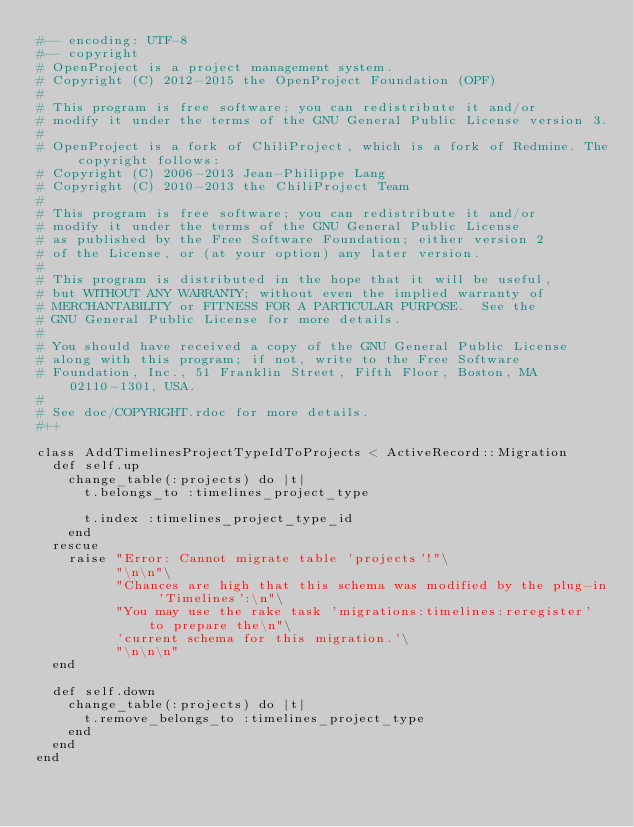<code> <loc_0><loc_0><loc_500><loc_500><_Ruby_>#-- encoding: UTF-8
#-- copyright
# OpenProject is a project management system.
# Copyright (C) 2012-2015 the OpenProject Foundation (OPF)
#
# This program is free software; you can redistribute it and/or
# modify it under the terms of the GNU General Public License version 3.
#
# OpenProject is a fork of ChiliProject, which is a fork of Redmine. The copyright follows:
# Copyright (C) 2006-2013 Jean-Philippe Lang
# Copyright (C) 2010-2013 the ChiliProject Team
#
# This program is free software; you can redistribute it and/or
# modify it under the terms of the GNU General Public License
# as published by the Free Software Foundation; either version 2
# of the License, or (at your option) any later version.
#
# This program is distributed in the hope that it will be useful,
# but WITHOUT ANY WARRANTY; without even the implied warranty of
# MERCHANTABILITY or FITNESS FOR A PARTICULAR PURPOSE.  See the
# GNU General Public License for more details.
#
# You should have received a copy of the GNU General Public License
# along with this program; if not, write to the Free Software
# Foundation, Inc., 51 Franklin Street, Fifth Floor, Boston, MA  02110-1301, USA.
#
# See doc/COPYRIGHT.rdoc for more details.
#++

class AddTimelinesProjectTypeIdToProjects < ActiveRecord::Migration
  def self.up
    change_table(:projects) do |t|
      t.belongs_to :timelines_project_type

      t.index :timelines_project_type_id
    end
  rescue
    raise "Error: Cannot migrate table 'projects'!"\
          "\n\n"\
          "Chances are high that this schema was modified by the plug-in 'Timelines':\n"\
          "You may use the rake task 'migrations:timelines:reregister' to prepare the\n"\
          'current schema for this migration.'\
          "\n\n\n"
  end

  def self.down
    change_table(:projects) do |t|
      t.remove_belongs_to :timelines_project_type
    end
  end
end
</code> 